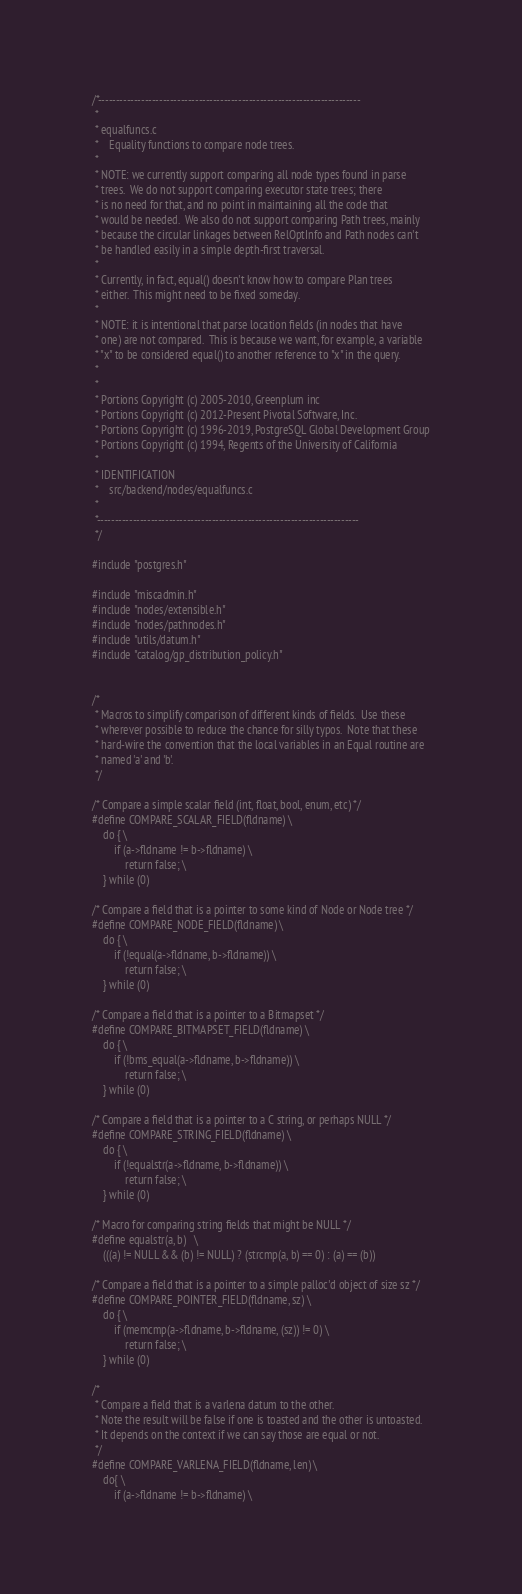Convert code to text. <code><loc_0><loc_0><loc_500><loc_500><_C_>/*-------------------------------------------------------------------------
 *
 * equalfuncs.c
 *	  Equality functions to compare node trees.
 *
 * NOTE: we currently support comparing all node types found in parse
 * trees.  We do not support comparing executor state trees; there
 * is no need for that, and no point in maintaining all the code that
 * would be needed.  We also do not support comparing Path trees, mainly
 * because the circular linkages between RelOptInfo and Path nodes can't
 * be handled easily in a simple depth-first traversal.
 *
 * Currently, in fact, equal() doesn't know how to compare Plan trees
 * either.  This might need to be fixed someday.
 *
 * NOTE: it is intentional that parse location fields (in nodes that have
 * one) are not compared.  This is because we want, for example, a variable
 * "x" to be considered equal() to another reference to "x" in the query.
 *
 *
 * Portions Copyright (c) 2005-2010, Greenplum inc
 * Portions Copyright (c) 2012-Present Pivotal Software, Inc.
 * Portions Copyright (c) 1996-2019, PostgreSQL Global Development Group
 * Portions Copyright (c) 1994, Regents of the University of California
 *
 * IDENTIFICATION
 *	  src/backend/nodes/equalfuncs.c
 *
 *-------------------------------------------------------------------------
 */

#include "postgres.h"

#include "miscadmin.h"
#include "nodes/extensible.h"
#include "nodes/pathnodes.h"
#include "utils/datum.h"
#include "catalog/gp_distribution_policy.h"


/*
 * Macros to simplify comparison of different kinds of fields.  Use these
 * wherever possible to reduce the chance for silly typos.  Note that these
 * hard-wire the convention that the local variables in an Equal routine are
 * named 'a' and 'b'.
 */

/* Compare a simple scalar field (int, float, bool, enum, etc) */
#define COMPARE_SCALAR_FIELD(fldname) \
	do { \
		if (a->fldname != b->fldname) \
			return false; \
	} while (0)

/* Compare a field that is a pointer to some kind of Node or Node tree */
#define COMPARE_NODE_FIELD(fldname) \
	do { \
		if (!equal(a->fldname, b->fldname)) \
			return false; \
	} while (0)

/* Compare a field that is a pointer to a Bitmapset */
#define COMPARE_BITMAPSET_FIELD(fldname) \
	do { \
		if (!bms_equal(a->fldname, b->fldname)) \
			return false; \
	} while (0)

/* Compare a field that is a pointer to a C string, or perhaps NULL */
#define COMPARE_STRING_FIELD(fldname) \
	do { \
		if (!equalstr(a->fldname, b->fldname)) \
			return false; \
	} while (0)

/* Macro for comparing string fields that might be NULL */
#define equalstr(a, b)	\
	(((a) != NULL && (b) != NULL) ? (strcmp(a, b) == 0) : (a) == (b))

/* Compare a field that is a pointer to a simple palloc'd object of size sz */
#define COMPARE_POINTER_FIELD(fldname, sz) \
	do { \
		if (memcmp(a->fldname, b->fldname, (sz)) != 0) \
			return false; \
	} while (0)

/*
 * Compare a field that is a varlena datum to the other.
 * Note the result will be false if one is toasted and the other is untoasted.
 * It depends on the context if we can say those are equal or not.
 */
#define COMPARE_VARLENA_FIELD(fldname, len) \
	do{ \
		if (a->fldname != b->fldname) \</code> 